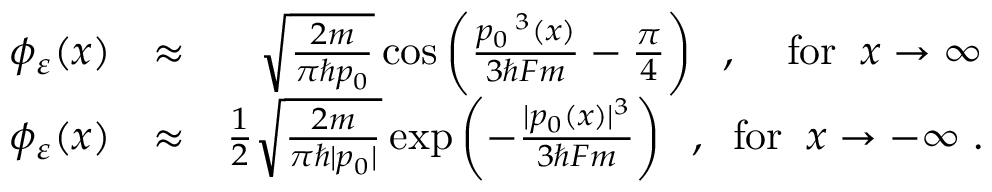<formula> <loc_0><loc_0><loc_500><loc_500>\begin{array} { r l r } { \phi _ { \varepsilon } ( x ) } & { \approx } & { \sqrt { \frac { 2 m } { \pi \hbar { p } _ { 0 } } } \cos \left ( \frac { p _ { 0 } \, ^ { 3 } ( x ) } { 3 \hbar { F } m } - \frac { \pi } { 4 } \right ) \, , \, f o r \, x \to \infty } \\ { \phi _ { \varepsilon } ( x ) } & { \approx } & { \frac { 1 } { 2 } \sqrt { \frac { 2 m } { \pi \hbar { | } p _ { 0 } | } } \exp \left ( - \frac { | p _ { 0 } ( x ) | ^ { 3 } } { 3 \hbar { F } m } \right ) \, , \, f o r \, x \to - \infty \, . } \end{array}</formula> 